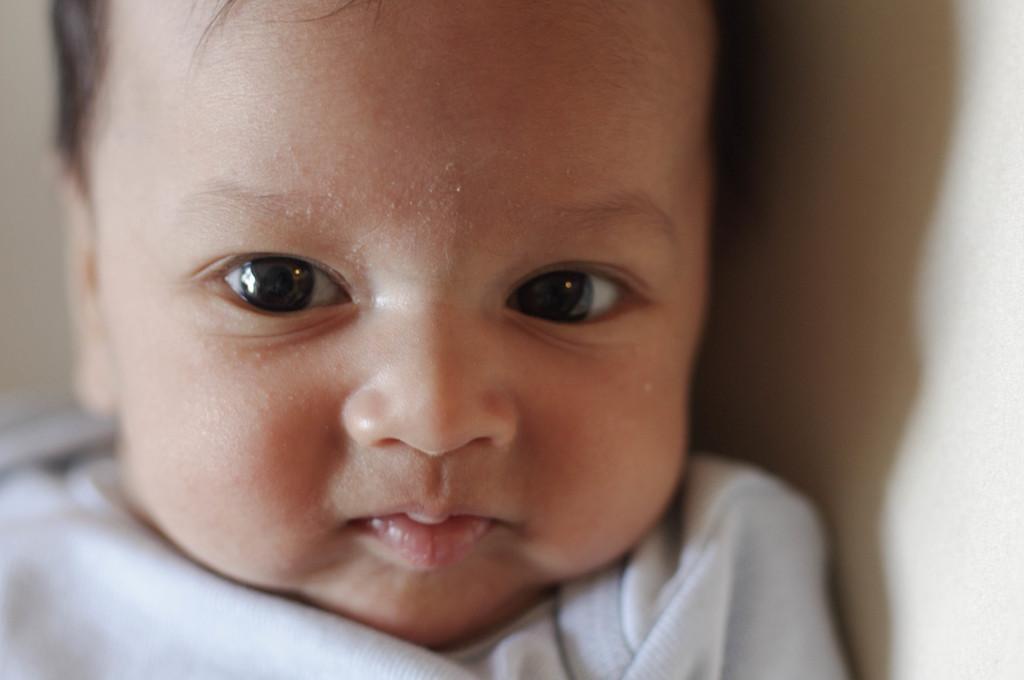Describe this image in one or two sentences. In this image there is a baby, in the background it is blurred. 